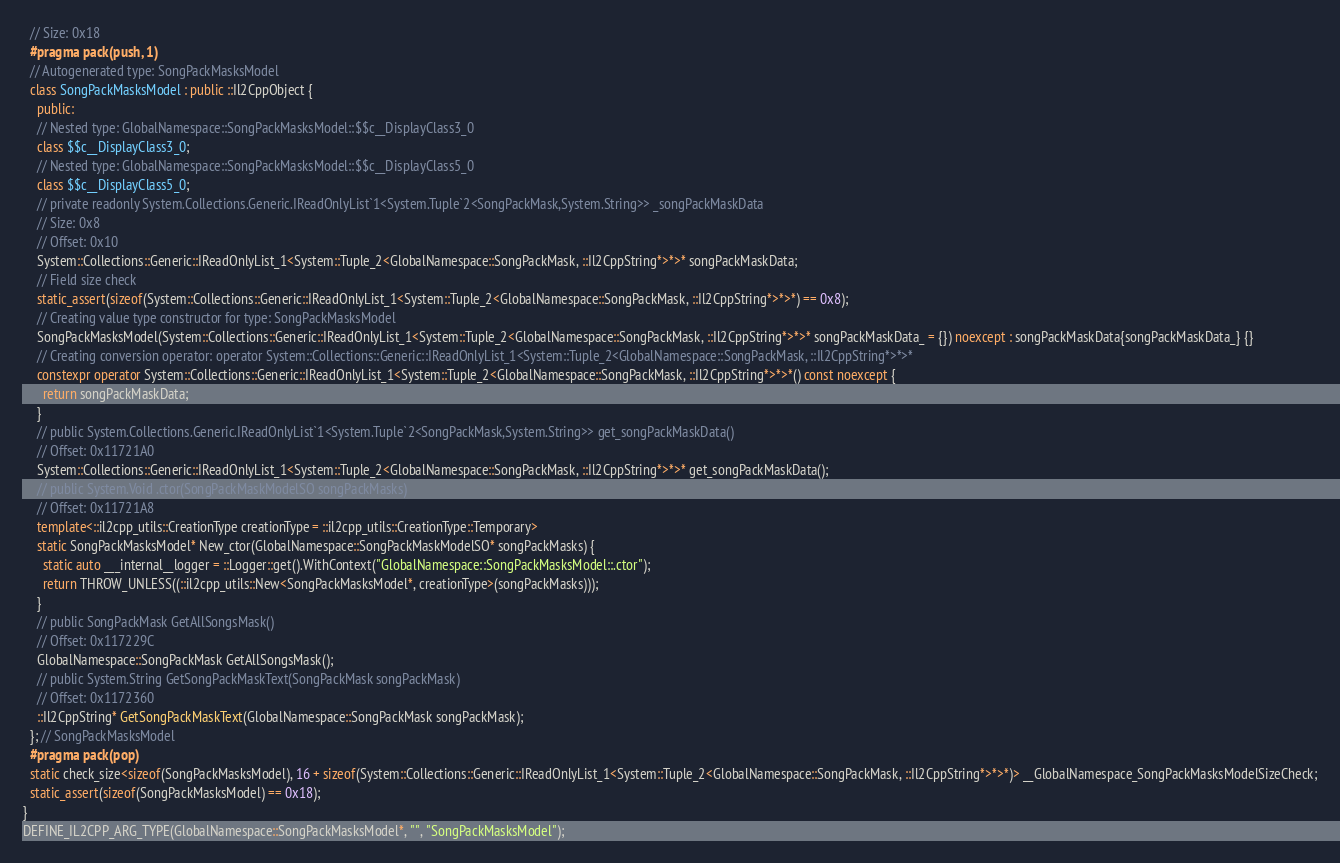<code> <loc_0><loc_0><loc_500><loc_500><_C++_>  // Size: 0x18
  #pragma pack(push, 1)
  // Autogenerated type: SongPackMasksModel
  class SongPackMasksModel : public ::Il2CppObject {
    public:
    // Nested type: GlobalNamespace::SongPackMasksModel::$$c__DisplayClass3_0
    class $$c__DisplayClass3_0;
    // Nested type: GlobalNamespace::SongPackMasksModel::$$c__DisplayClass5_0
    class $$c__DisplayClass5_0;
    // private readonly System.Collections.Generic.IReadOnlyList`1<System.Tuple`2<SongPackMask,System.String>> _songPackMaskData
    // Size: 0x8
    // Offset: 0x10
    System::Collections::Generic::IReadOnlyList_1<System::Tuple_2<GlobalNamespace::SongPackMask, ::Il2CppString*>*>* songPackMaskData;
    // Field size check
    static_assert(sizeof(System::Collections::Generic::IReadOnlyList_1<System::Tuple_2<GlobalNamespace::SongPackMask, ::Il2CppString*>*>*) == 0x8);
    // Creating value type constructor for type: SongPackMasksModel
    SongPackMasksModel(System::Collections::Generic::IReadOnlyList_1<System::Tuple_2<GlobalNamespace::SongPackMask, ::Il2CppString*>*>* songPackMaskData_ = {}) noexcept : songPackMaskData{songPackMaskData_} {}
    // Creating conversion operator: operator System::Collections::Generic::IReadOnlyList_1<System::Tuple_2<GlobalNamespace::SongPackMask, ::Il2CppString*>*>*
    constexpr operator System::Collections::Generic::IReadOnlyList_1<System::Tuple_2<GlobalNamespace::SongPackMask, ::Il2CppString*>*>*() const noexcept {
      return songPackMaskData;
    }
    // public System.Collections.Generic.IReadOnlyList`1<System.Tuple`2<SongPackMask,System.String>> get_songPackMaskData()
    // Offset: 0x11721A0
    System::Collections::Generic::IReadOnlyList_1<System::Tuple_2<GlobalNamespace::SongPackMask, ::Il2CppString*>*>* get_songPackMaskData();
    // public System.Void .ctor(SongPackMaskModelSO songPackMasks)
    // Offset: 0x11721A8
    template<::il2cpp_utils::CreationType creationType = ::il2cpp_utils::CreationType::Temporary>
    static SongPackMasksModel* New_ctor(GlobalNamespace::SongPackMaskModelSO* songPackMasks) {
      static auto ___internal__logger = ::Logger::get().WithContext("GlobalNamespace::SongPackMasksModel::.ctor");
      return THROW_UNLESS((::il2cpp_utils::New<SongPackMasksModel*, creationType>(songPackMasks)));
    }
    // public SongPackMask GetAllSongsMask()
    // Offset: 0x117229C
    GlobalNamespace::SongPackMask GetAllSongsMask();
    // public System.String GetSongPackMaskText(SongPackMask songPackMask)
    // Offset: 0x1172360
    ::Il2CppString* GetSongPackMaskText(GlobalNamespace::SongPackMask songPackMask);
  }; // SongPackMasksModel
  #pragma pack(pop)
  static check_size<sizeof(SongPackMasksModel), 16 + sizeof(System::Collections::Generic::IReadOnlyList_1<System::Tuple_2<GlobalNamespace::SongPackMask, ::Il2CppString*>*>*)> __GlobalNamespace_SongPackMasksModelSizeCheck;
  static_assert(sizeof(SongPackMasksModel) == 0x18);
}
DEFINE_IL2CPP_ARG_TYPE(GlobalNamespace::SongPackMasksModel*, "", "SongPackMasksModel");
</code> 